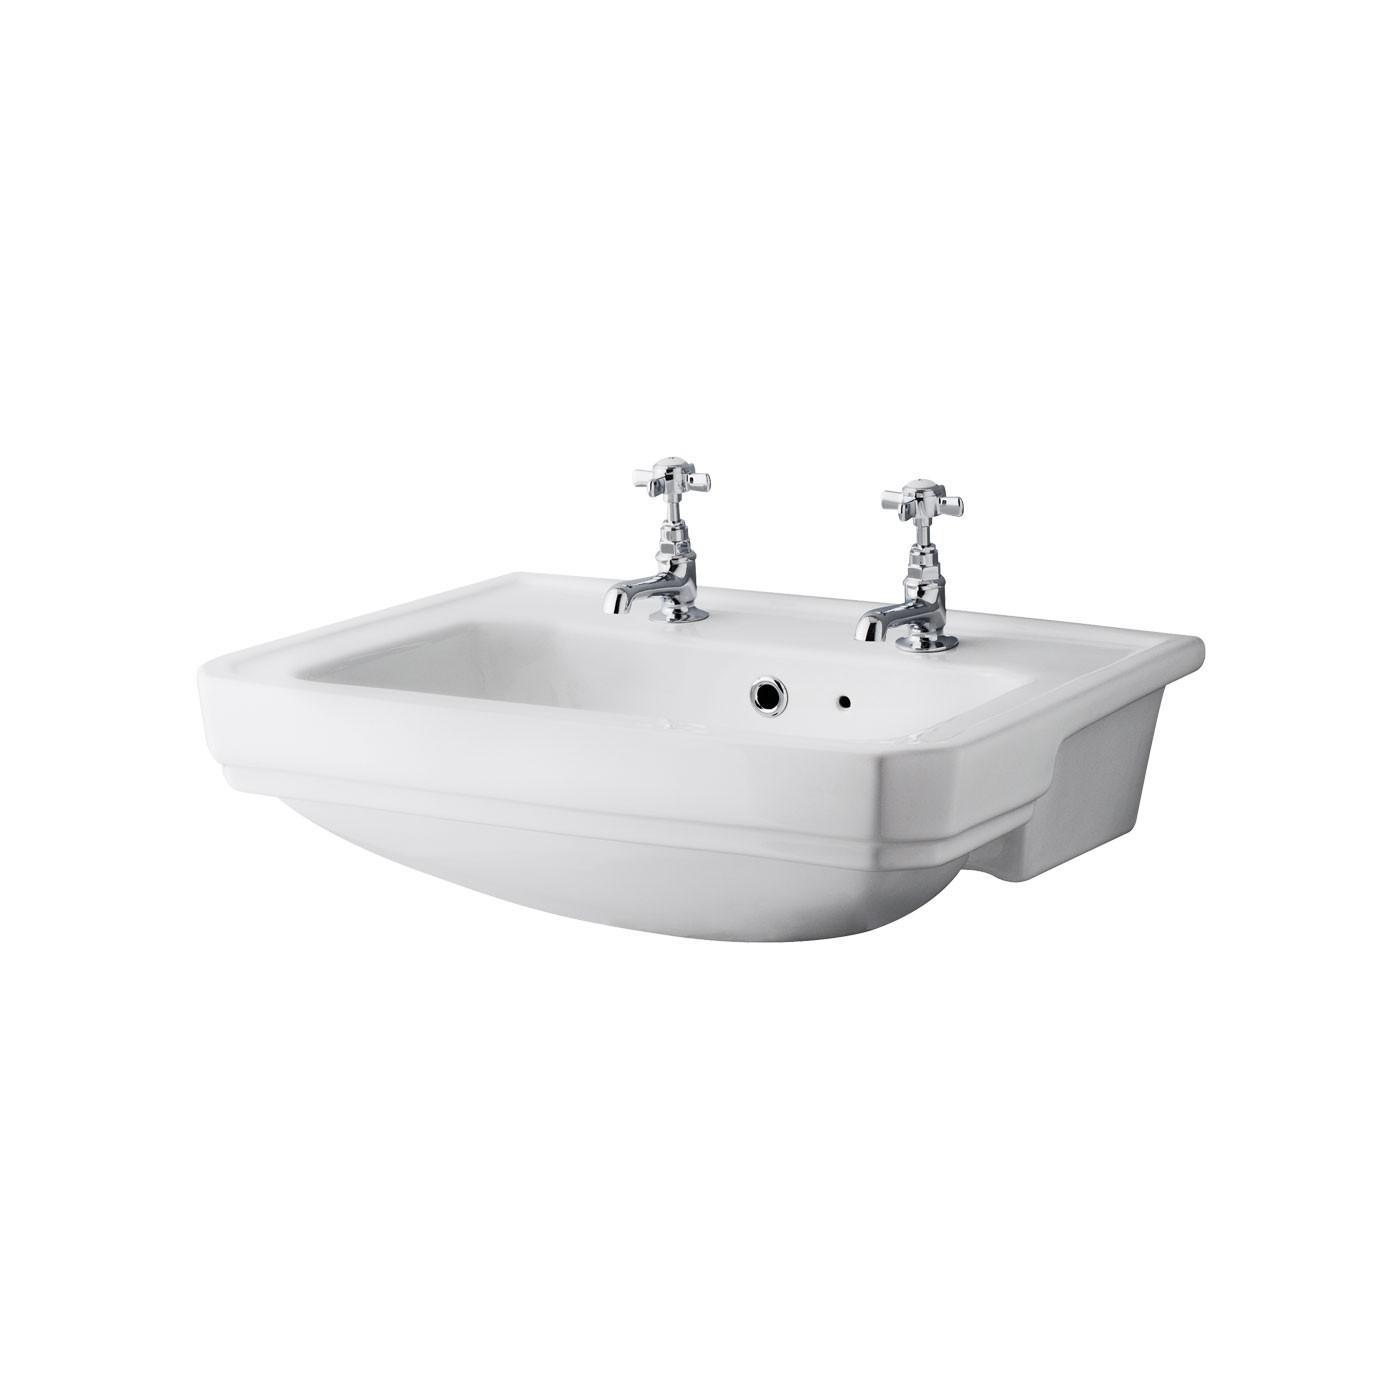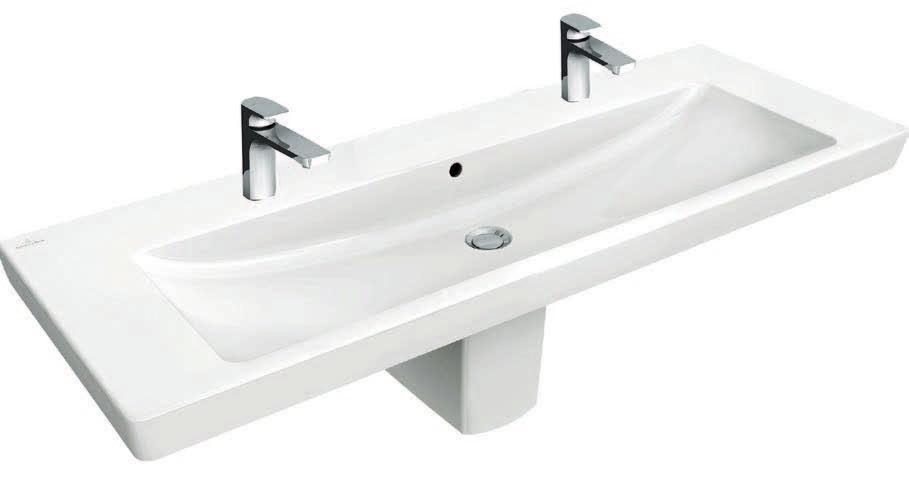The first image is the image on the left, the second image is the image on the right. Assess this claim about the two images: "None of the faucets are the rotating kind.". Correct or not? Answer yes or no. No. 